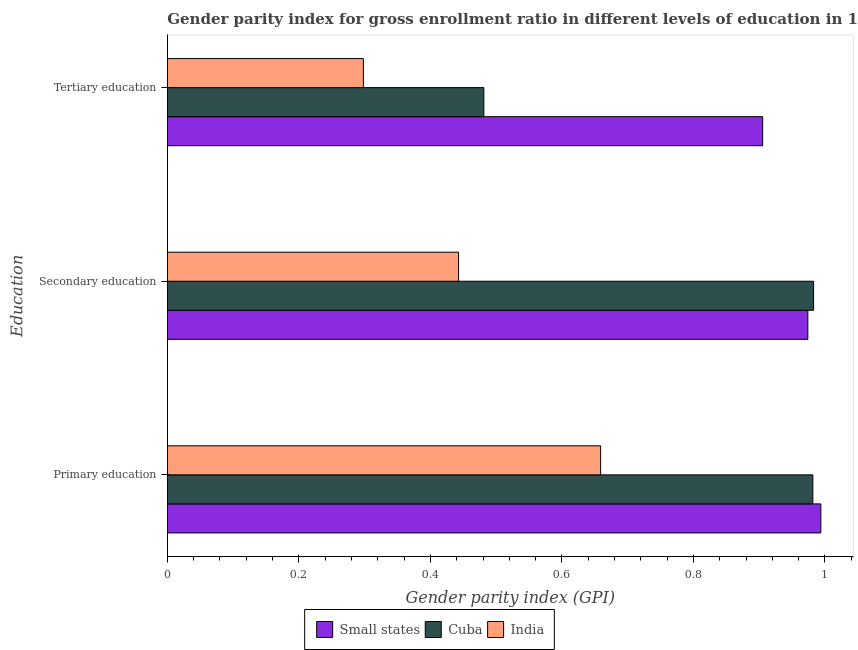How many different coloured bars are there?
Provide a succinct answer. 3. Are the number of bars per tick equal to the number of legend labels?
Offer a very short reply. Yes. How many bars are there on the 1st tick from the bottom?
Keep it short and to the point. 3. What is the label of the 1st group of bars from the top?
Your answer should be compact. Tertiary education. What is the gender parity index in primary education in Small states?
Offer a terse response. 0.99. Across all countries, what is the maximum gender parity index in primary education?
Provide a short and direct response. 0.99. Across all countries, what is the minimum gender parity index in secondary education?
Offer a very short reply. 0.44. In which country was the gender parity index in secondary education maximum?
Keep it short and to the point. Cuba. What is the total gender parity index in primary education in the graph?
Your answer should be very brief. 2.63. What is the difference between the gender parity index in secondary education in India and that in Cuba?
Your answer should be compact. -0.54. What is the difference between the gender parity index in primary education in Small states and the gender parity index in secondary education in India?
Provide a short and direct response. 0.55. What is the average gender parity index in primary education per country?
Your response must be concise. 0.88. What is the difference between the gender parity index in secondary education and gender parity index in tertiary education in India?
Provide a short and direct response. 0.14. What is the ratio of the gender parity index in tertiary education in Small states to that in Cuba?
Give a very brief answer. 1.88. Is the gender parity index in secondary education in Small states less than that in India?
Give a very brief answer. No. What is the difference between the highest and the second highest gender parity index in secondary education?
Your response must be concise. 0.01. What is the difference between the highest and the lowest gender parity index in secondary education?
Ensure brevity in your answer.  0.54. What does the 2nd bar from the top in Primary education represents?
Provide a succinct answer. Cuba. What does the 2nd bar from the bottom in Tertiary education represents?
Your answer should be very brief. Cuba. How many bars are there?
Your answer should be compact. 9. How are the legend labels stacked?
Provide a succinct answer. Horizontal. What is the title of the graph?
Provide a succinct answer. Gender parity index for gross enrollment ratio in different levels of education in 1973. What is the label or title of the X-axis?
Your answer should be very brief. Gender parity index (GPI). What is the label or title of the Y-axis?
Keep it short and to the point. Education. What is the Gender parity index (GPI) of Small states in Primary education?
Your answer should be very brief. 0.99. What is the Gender parity index (GPI) in Cuba in Primary education?
Provide a succinct answer. 0.98. What is the Gender parity index (GPI) in India in Primary education?
Offer a terse response. 0.66. What is the Gender parity index (GPI) of Small states in Secondary education?
Keep it short and to the point. 0.97. What is the Gender parity index (GPI) of Cuba in Secondary education?
Your answer should be compact. 0.98. What is the Gender parity index (GPI) of India in Secondary education?
Keep it short and to the point. 0.44. What is the Gender parity index (GPI) in Small states in Tertiary education?
Offer a very short reply. 0.91. What is the Gender parity index (GPI) in Cuba in Tertiary education?
Ensure brevity in your answer.  0.48. What is the Gender parity index (GPI) of India in Tertiary education?
Your answer should be very brief. 0.3. Across all Education, what is the maximum Gender parity index (GPI) in Small states?
Provide a short and direct response. 0.99. Across all Education, what is the maximum Gender parity index (GPI) in Cuba?
Make the answer very short. 0.98. Across all Education, what is the maximum Gender parity index (GPI) of India?
Offer a terse response. 0.66. Across all Education, what is the minimum Gender parity index (GPI) of Small states?
Offer a very short reply. 0.91. Across all Education, what is the minimum Gender parity index (GPI) of Cuba?
Your response must be concise. 0.48. Across all Education, what is the minimum Gender parity index (GPI) in India?
Ensure brevity in your answer.  0.3. What is the total Gender parity index (GPI) in Small states in the graph?
Give a very brief answer. 2.87. What is the total Gender parity index (GPI) of Cuba in the graph?
Make the answer very short. 2.45. What is the total Gender parity index (GPI) of India in the graph?
Give a very brief answer. 1.4. What is the difference between the Gender parity index (GPI) of Small states in Primary education and that in Secondary education?
Your answer should be very brief. 0.02. What is the difference between the Gender parity index (GPI) of Cuba in Primary education and that in Secondary education?
Give a very brief answer. -0. What is the difference between the Gender parity index (GPI) in India in Primary education and that in Secondary education?
Give a very brief answer. 0.22. What is the difference between the Gender parity index (GPI) of Small states in Primary education and that in Tertiary education?
Keep it short and to the point. 0.09. What is the difference between the Gender parity index (GPI) in Cuba in Primary education and that in Tertiary education?
Provide a short and direct response. 0.5. What is the difference between the Gender parity index (GPI) in India in Primary education and that in Tertiary education?
Your response must be concise. 0.36. What is the difference between the Gender parity index (GPI) in Small states in Secondary education and that in Tertiary education?
Provide a short and direct response. 0.07. What is the difference between the Gender parity index (GPI) of Cuba in Secondary education and that in Tertiary education?
Provide a succinct answer. 0.5. What is the difference between the Gender parity index (GPI) of India in Secondary education and that in Tertiary education?
Offer a very short reply. 0.14. What is the difference between the Gender parity index (GPI) in Small states in Primary education and the Gender parity index (GPI) in Cuba in Secondary education?
Make the answer very short. 0.01. What is the difference between the Gender parity index (GPI) in Small states in Primary education and the Gender parity index (GPI) in India in Secondary education?
Your answer should be very brief. 0.55. What is the difference between the Gender parity index (GPI) of Cuba in Primary education and the Gender parity index (GPI) of India in Secondary education?
Your answer should be compact. 0.54. What is the difference between the Gender parity index (GPI) in Small states in Primary education and the Gender parity index (GPI) in Cuba in Tertiary education?
Ensure brevity in your answer.  0.51. What is the difference between the Gender parity index (GPI) in Small states in Primary education and the Gender parity index (GPI) in India in Tertiary education?
Provide a short and direct response. 0.7. What is the difference between the Gender parity index (GPI) of Cuba in Primary education and the Gender parity index (GPI) of India in Tertiary education?
Your answer should be very brief. 0.68. What is the difference between the Gender parity index (GPI) of Small states in Secondary education and the Gender parity index (GPI) of Cuba in Tertiary education?
Provide a succinct answer. 0.49. What is the difference between the Gender parity index (GPI) of Small states in Secondary education and the Gender parity index (GPI) of India in Tertiary education?
Provide a short and direct response. 0.68. What is the difference between the Gender parity index (GPI) in Cuba in Secondary education and the Gender parity index (GPI) in India in Tertiary education?
Make the answer very short. 0.68. What is the average Gender parity index (GPI) in Small states per Education?
Keep it short and to the point. 0.96. What is the average Gender parity index (GPI) in Cuba per Education?
Keep it short and to the point. 0.82. What is the average Gender parity index (GPI) of India per Education?
Keep it short and to the point. 0.47. What is the difference between the Gender parity index (GPI) of Small states and Gender parity index (GPI) of Cuba in Primary education?
Ensure brevity in your answer.  0.01. What is the difference between the Gender parity index (GPI) in Small states and Gender parity index (GPI) in India in Primary education?
Keep it short and to the point. 0.33. What is the difference between the Gender parity index (GPI) in Cuba and Gender parity index (GPI) in India in Primary education?
Provide a succinct answer. 0.32. What is the difference between the Gender parity index (GPI) of Small states and Gender parity index (GPI) of Cuba in Secondary education?
Provide a short and direct response. -0.01. What is the difference between the Gender parity index (GPI) of Small states and Gender parity index (GPI) of India in Secondary education?
Keep it short and to the point. 0.53. What is the difference between the Gender parity index (GPI) in Cuba and Gender parity index (GPI) in India in Secondary education?
Make the answer very short. 0.54. What is the difference between the Gender parity index (GPI) in Small states and Gender parity index (GPI) in Cuba in Tertiary education?
Your answer should be very brief. 0.42. What is the difference between the Gender parity index (GPI) in Small states and Gender parity index (GPI) in India in Tertiary education?
Your answer should be very brief. 0.61. What is the difference between the Gender parity index (GPI) of Cuba and Gender parity index (GPI) of India in Tertiary education?
Provide a succinct answer. 0.18. What is the ratio of the Gender parity index (GPI) of Small states in Primary education to that in Secondary education?
Give a very brief answer. 1.02. What is the ratio of the Gender parity index (GPI) in India in Primary education to that in Secondary education?
Ensure brevity in your answer.  1.49. What is the ratio of the Gender parity index (GPI) of Small states in Primary education to that in Tertiary education?
Offer a terse response. 1.1. What is the ratio of the Gender parity index (GPI) of Cuba in Primary education to that in Tertiary education?
Your response must be concise. 2.04. What is the ratio of the Gender parity index (GPI) in India in Primary education to that in Tertiary education?
Make the answer very short. 2.21. What is the ratio of the Gender parity index (GPI) in Small states in Secondary education to that in Tertiary education?
Provide a short and direct response. 1.08. What is the ratio of the Gender parity index (GPI) of Cuba in Secondary education to that in Tertiary education?
Provide a short and direct response. 2.04. What is the ratio of the Gender parity index (GPI) in India in Secondary education to that in Tertiary education?
Keep it short and to the point. 1.49. What is the difference between the highest and the second highest Gender parity index (GPI) of Small states?
Keep it short and to the point. 0.02. What is the difference between the highest and the second highest Gender parity index (GPI) of Cuba?
Make the answer very short. 0. What is the difference between the highest and the second highest Gender parity index (GPI) in India?
Offer a terse response. 0.22. What is the difference between the highest and the lowest Gender parity index (GPI) in Small states?
Give a very brief answer. 0.09. What is the difference between the highest and the lowest Gender parity index (GPI) of Cuba?
Offer a very short reply. 0.5. What is the difference between the highest and the lowest Gender parity index (GPI) of India?
Ensure brevity in your answer.  0.36. 